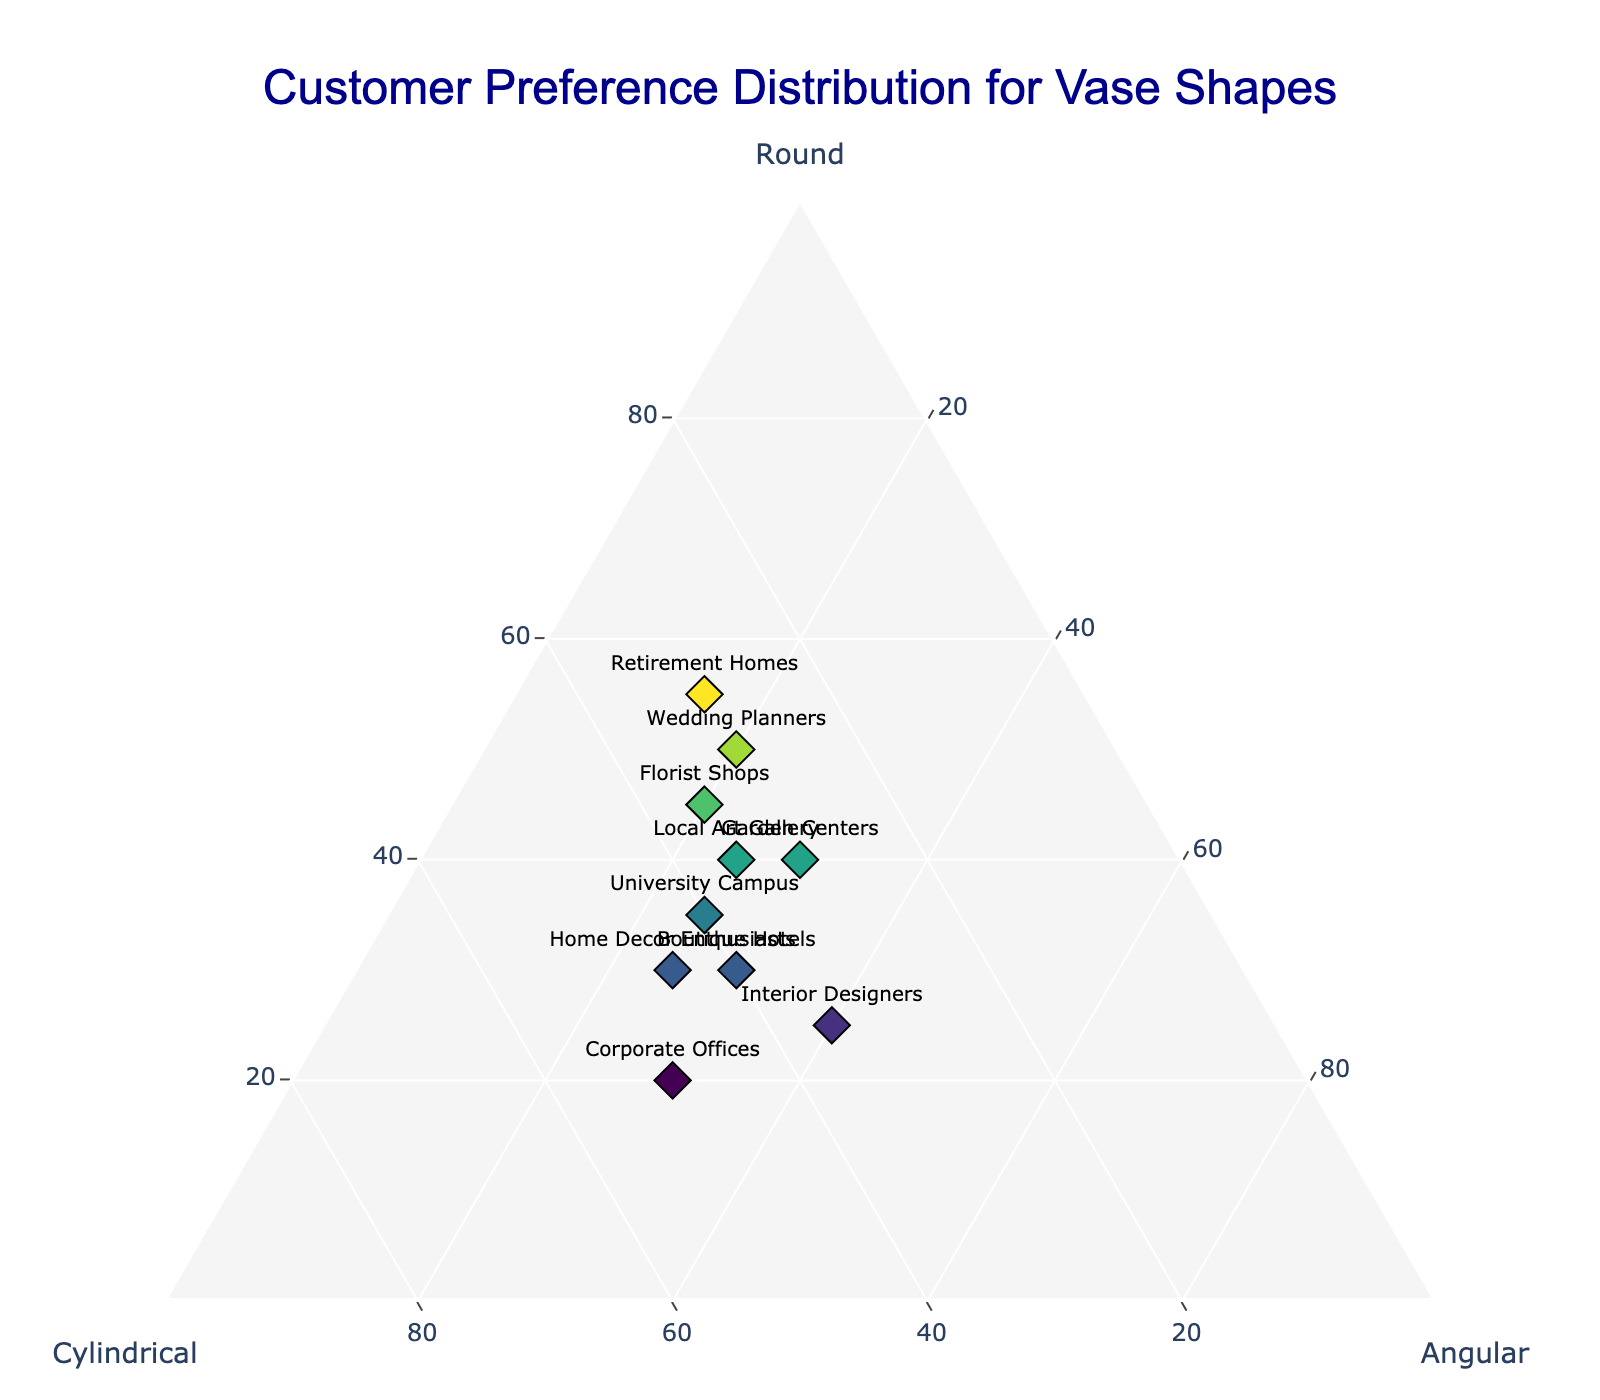How many customer groups have a preference for round vases above 40%? By examining the ternary plot and checking for points where the 'Round' axis value is above 40, we can count these groups: Wedding Planners, Florist Shops, Retirement Homes, and Local Art Gallery.
Answer: 4 Which customer group has the highest preference for cylindrical vases? The data point that is closest to the Cylindrical vertex indicates the highest preference. This is the Corporate Offices group with 50% preference for cylindrical vases.
Answer: Corporate Offices What's the average preference for angular vases across all customer groups? Summing the 'Angular' preferences: 25 + 25 + 20 + 30 + 25 + 20 + 40 + 15 + 30 + 30 = 260, then divide by the number of groups, which is 10. 260 / 10 = 26.
Answer: 26 Between Local Art Gallery and Wedding Planners, which group has a higher preference for round vases? By comparing the 'Round' preference values, Local Art Gallery has 40% and Wedding Planners have 50%. Therefore, Wedding Planners have a higher preference.
Answer: Wedding Planners Which customer group has the most balanced preference across all three shapes (round, cylindrical, angular)? The group closest to the centroid (center) of the ternary plot will be most balanced. The Boutique Hotels group with values (30, 40, 30) is nearest to the equilibrium point.
Answer: Boutique Hotels Is there any customer group with exactly equal preferences for round and cylindrical vases? By checking the axes, none of the points have equal values for 'Round' and 'Cylindrical'.
Answer: No Which group has the least preference for angular vases? The point farthest from the Angular vertex or the lowest value on the Angular axis reveals the group. Retirement Homes have the least preference with 15%.
Answer: Retirement Homes How many customer groups prefer round vases more than cylindrical vases? Identify groups where 'Round' > 'Cylindrical': Local Art Gallery, Wedding Planners, Florist Shops, Retirement Homes, and Garden Centers.
Answer: 5 If the total preference for a shape across all groups must reach 1000%, how much more is needed for round vases given their current total? The current sum of 'Round' preferences: 40 + 30 + 50 + 20 + 35 + 45 + 25 + 55 + 30 + 40 = 370. Since it must reach 1000%, the remaining amount needed is 1000 - 370 = 630.
Answer: 630 What is the combined preference of Corporate Offices and University Campus for cylindrical vases? Summing the 'Cylindrical' preferences of Corporate Offices (50) and University Campus (40) gives 50 + 40 = 90.
Answer: 90 